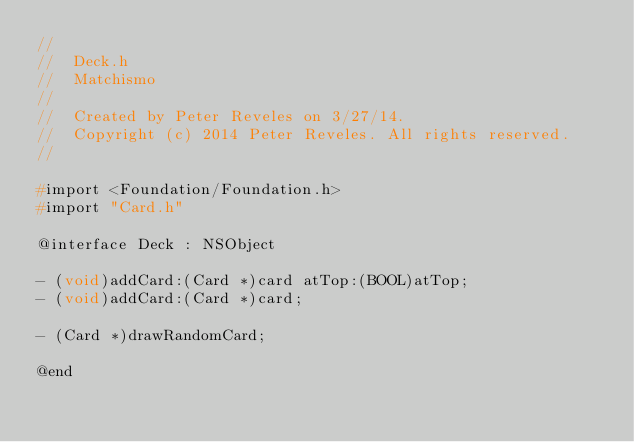Convert code to text. <code><loc_0><loc_0><loc_500><loc_500><_C_>//
//  Deck.h
//  Matchismo
//
//  Created by Peter Reveles on 3/27/14.
//  Copyright (c) 2014 Peter Reveles. All rights reserved.
//

#import <Foundation/Foundation.h>
#import "Card.h"

@interface Deck : NSObject

- (void)addCard:(Card *)card atTop:(BOOL)atTop;
- (void)addCard:(Card *)card;

- (Card *)drawRandomCard;

@end
</code> 